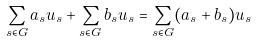<formula> <loc_0><loc_0><loc_500><loc_500>\sum _ { s \in G } a _ { s } u _ { s } + \sum _ { s \in G } b _ { s } u _ { s } = \sum _ { s \in G } ( a _ { s } + b _ { s } ) u _ { s }</formula> 